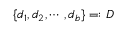<formula> <loc_0><loc_0><loc_500><loc_500>\{ d _ { 1 } , d _ { 2 } , \dots b , d _ { b } \} = \colon D</formula> 